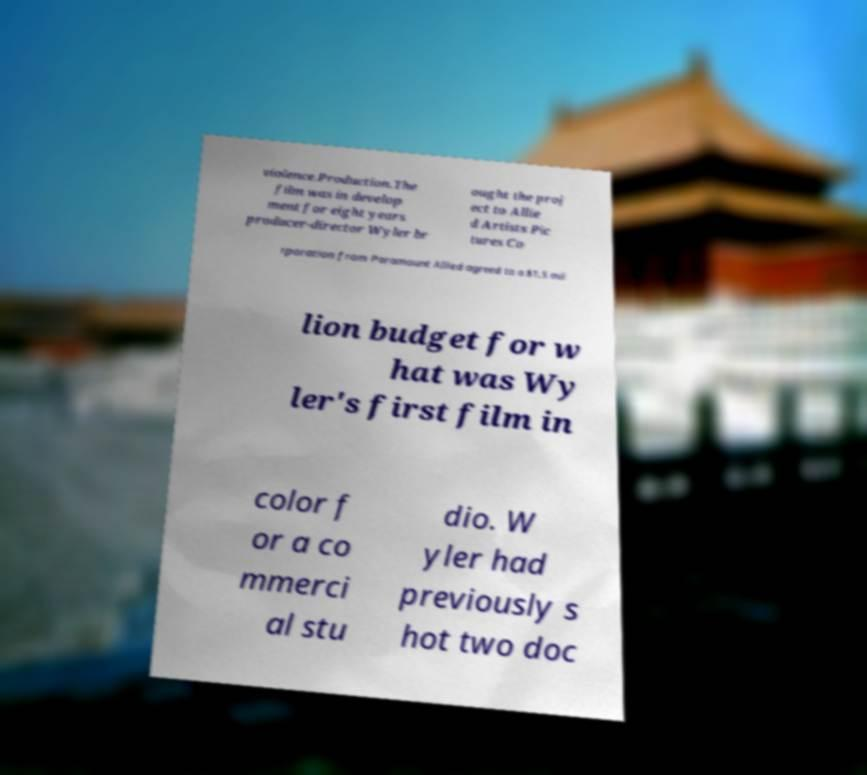For documentation purposes, I need the text within this image transcribed. Could you provide that? violence.Production.The film was in develop ment for eight years producer-director Wyler br ought the proj ect to Allie d Artists Pic tures Co rporation from Paramount Allied agreed to a $1.5 mil lion budget for w hat was Wy ler's first film in color f or a co mmerci al stu dio. W yler had previously s hot two doc 